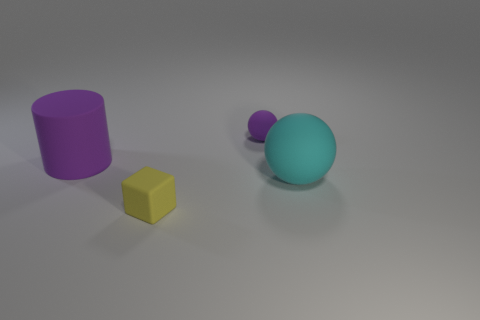Subtract 0 brown cubes. How many objects are left? 4 Subtract all cylinders. How many objects are left? 3 Subtract 1 blocks. How many blocks are left? 0 Subtract all brown cylinders. Subtract all cyan balls. How many cylinders are left? 1 Subtract all red blocks. How many purple balls are left? 1 Subtract all yellow matte cubes. Subtract all big balls. How many objects are left? 2 Add 1 purple balls. How many purple balls are left? 2 Add 4 tiny matte balls. How many tiny matte balls exist? 5 Add 1 big purple matte objects. How many objects exist? 5 